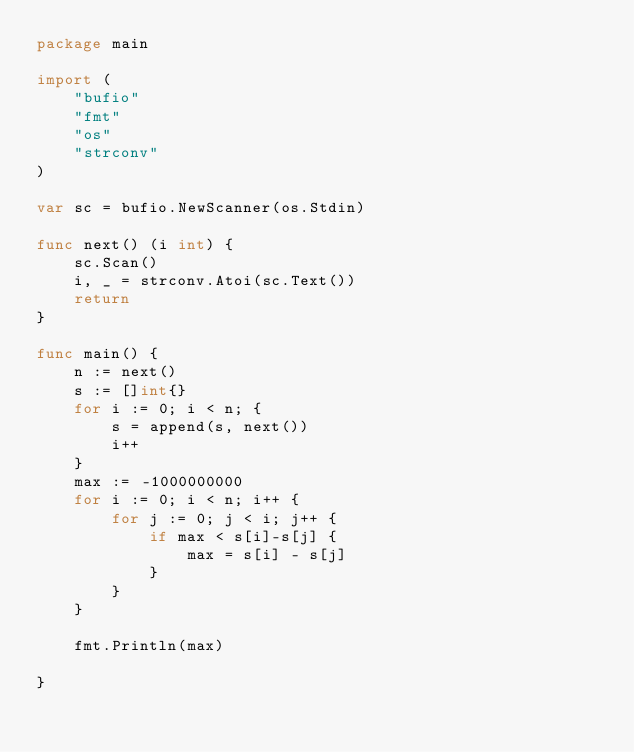Convert code to text. <code><loc_0><loc_0><loc_500><loc_500><_Go_>package main

import (
	"bufio"
	"fmt"
	"os"
	"strconv"
)

var sc = bufio.NewScanner(os.Stdin)

func next() (i int) {
	sc.Scan()
	i, _ = strconv.Atoi(sc.Text())
	return
}

func main() {
	n := next()
	s := []int{}
	for i := 0; i < n; {
		s = append(s, next())
		i++
	}
	max := -1000000000
	for i := 0; i < n; i++ {
		for j := 0; j < i; j++ {
			if max < s[i]-s[j] {
				max = s[i] - s[j]
			}
		}
	}

	fmt.Println(max)

}
</code> 